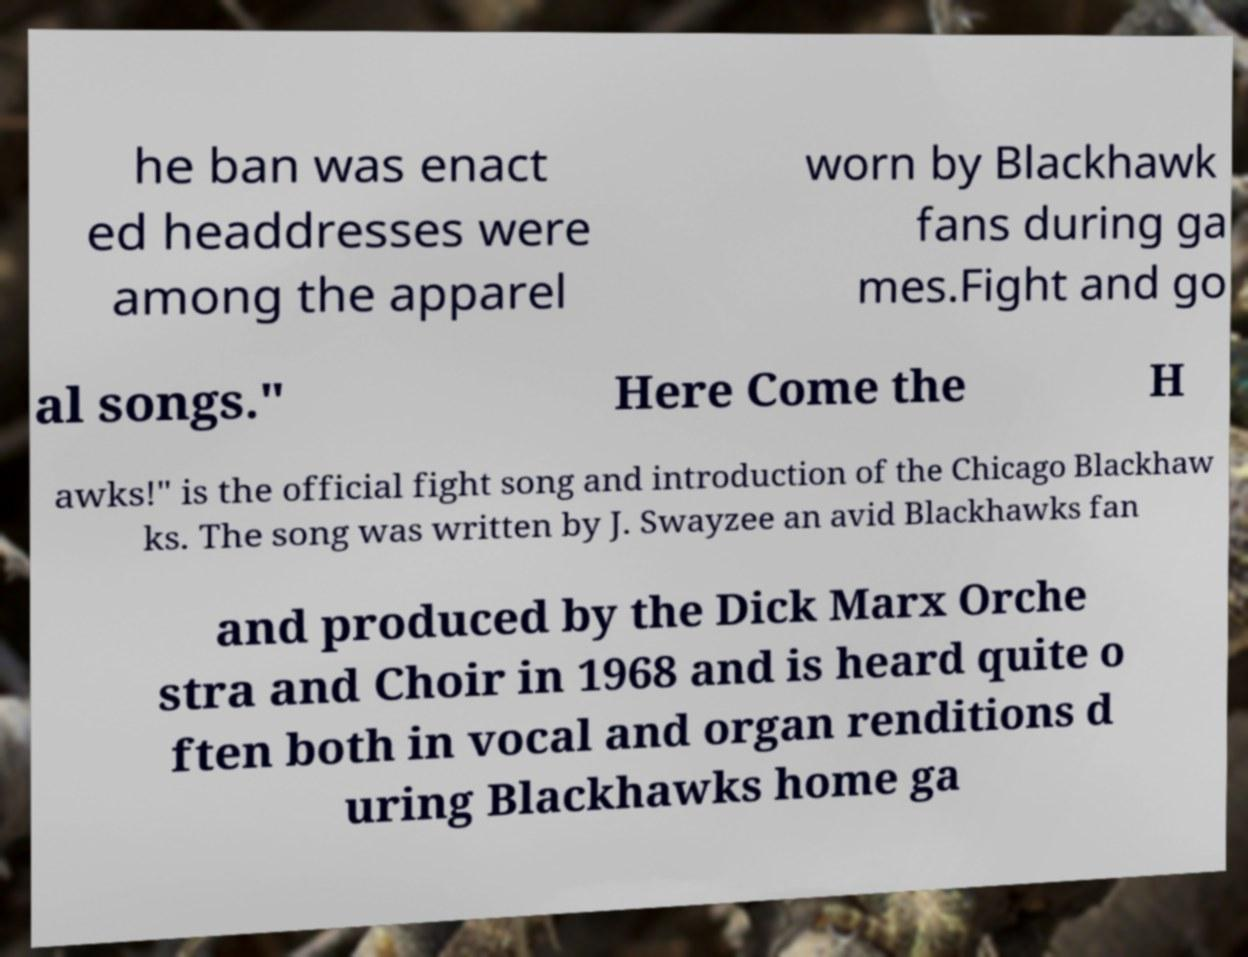What messages or text are displayed in this image? I need them in a readable, typed format. he ban was enact ed headdresses were among the apparel worn by Blackhawk fans during ga mes.Fight and go al songs." Here Come the H awks!" is the official fight song and introduction of the Chicago Blackhaw ks. The song was written by J. Swayzee an avid Blackhawks fan and produced by the Dick Marx Orche stra and Choir in 1968 and is heard quite o ften both in vocal and organ renditions d uring Blackhawks home ga 